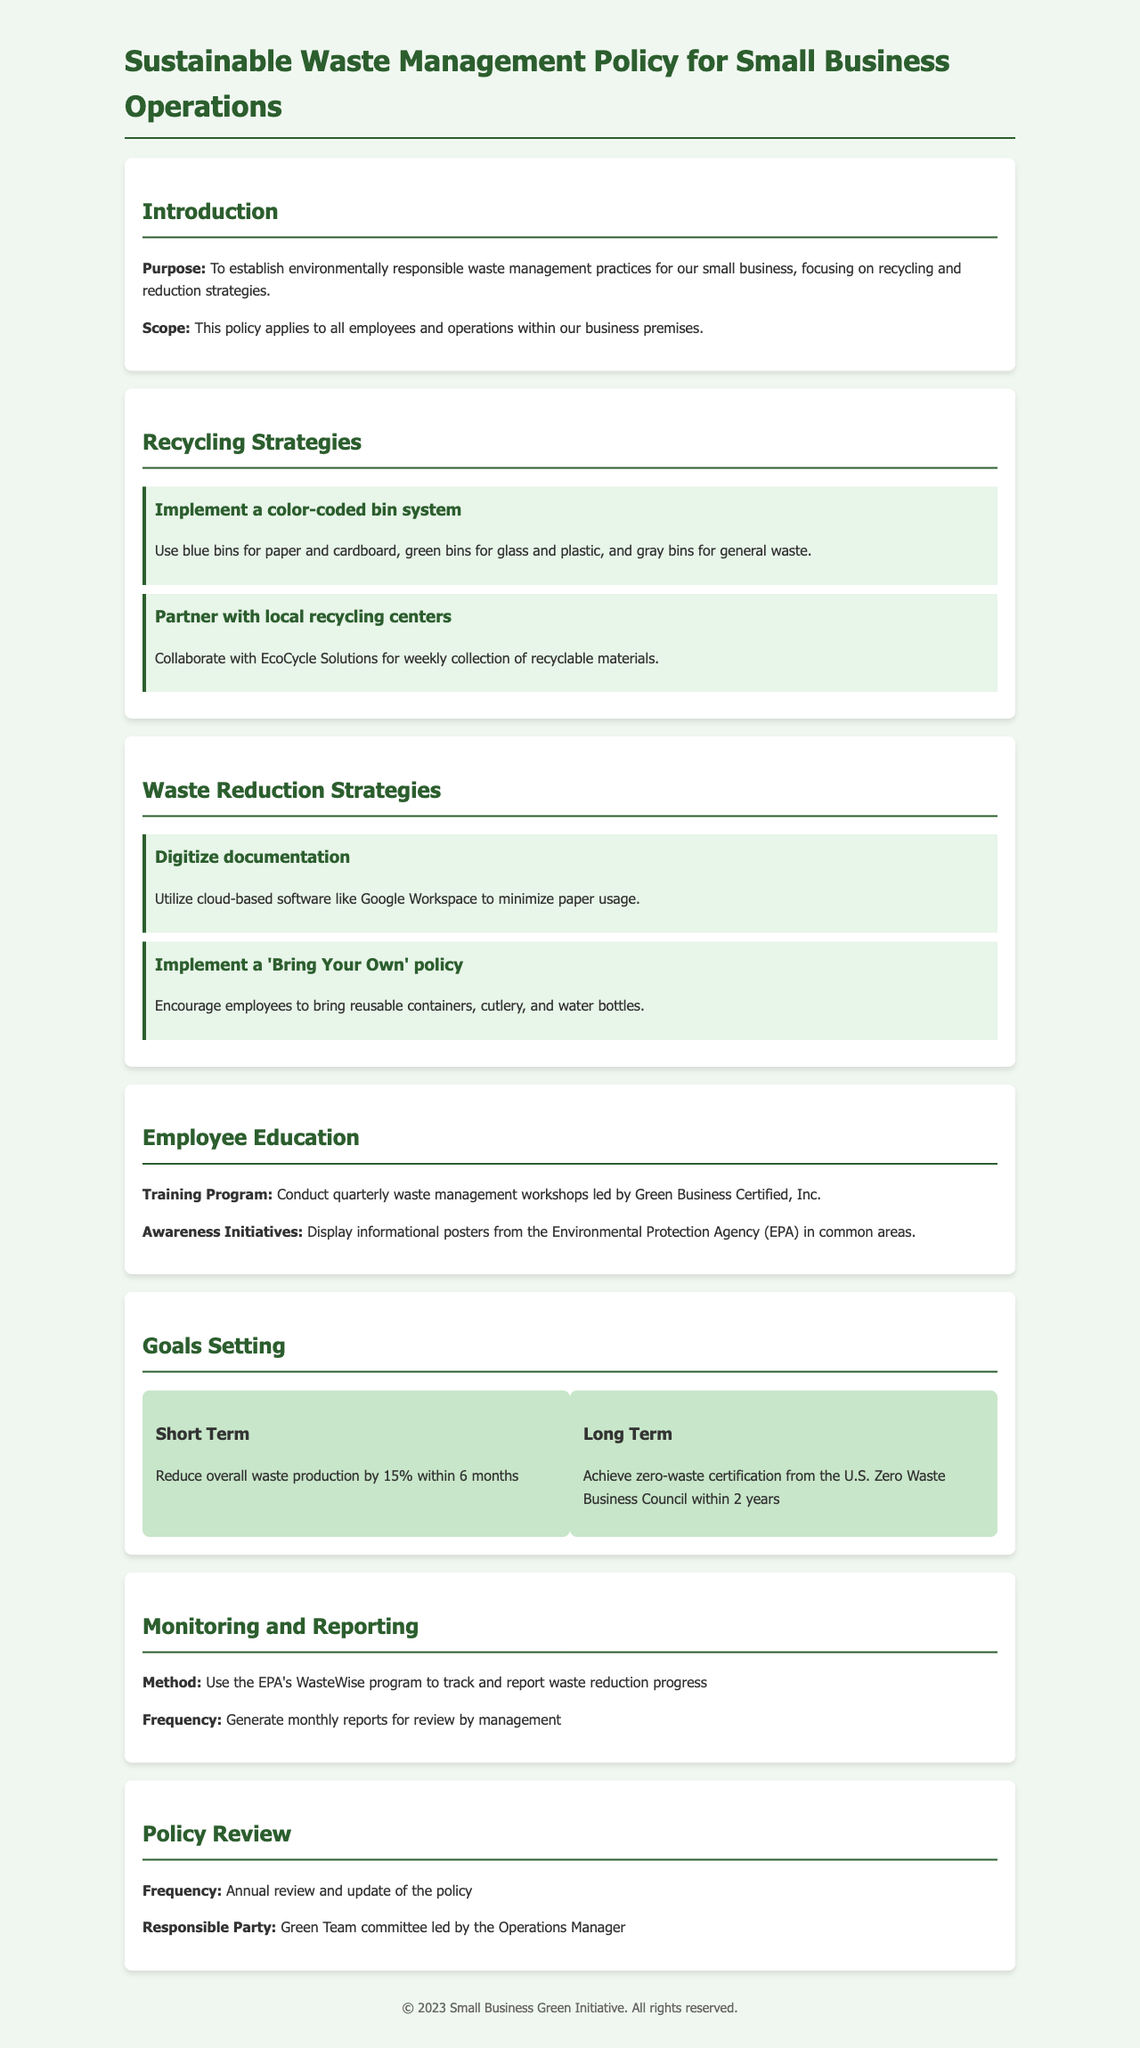What is the purpose of the policy? The purpose is to establish environmentally responsible waste management practices for the small business.
Answer: environmentally responsible waste management practices What is the recycling center mentioned in the strategies? The document mentions partnering with EcoCycle Solutions for the collection of recyclable materials.
Answer: EcoCycle Solutions How many short-term goals are mentioned? The document lists one short-term goal to reduce waste production.
Answer: 1 What is the target percentage for waste reduction within 6 months? The target percentage for waste reduction is stated as 15%.
Answer: 15% Who is responsible for the annual review of the policy? The Green Team committee led by the Operations Manager is responsible for the annual review.
Answer: Green Team committee What software is suggested for digitizing documentation? The document suggests using cloud-based software like Google Workspace.
Answer: Google Workspace How often will waste management workshops be conducted? The workshops are planned to be conducted quarterly.
Answer: quarterly What is the long-term goal stated in the policy? The long-term goal is to achieve zero-waste certification from the U.S. Zero Waste Business Council.
Answer: zero-waste certification What is the frequency of monitoring and reporting waste reduction progress? The document mentions generating monthly reports for waste reduction progress.
Answer: monthly 